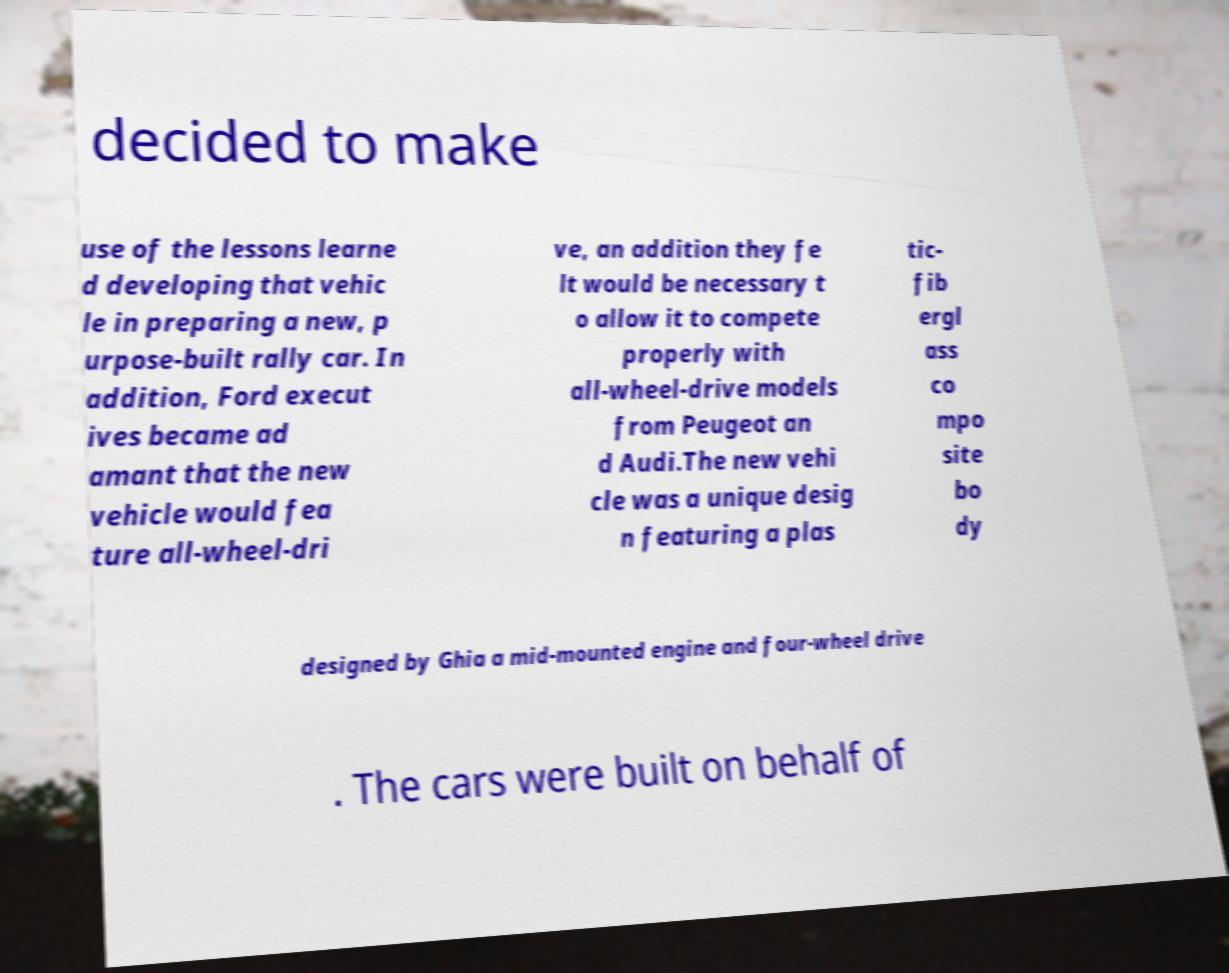Can you read and provide the text displayed in the image?This photo seems to have some interesting text. Can you extract and type it out for me? decided to make use of the lessons learne d developing that vehic le in preparing a new, p urpose-built rally car. In addition, Ford execut ives became ad amant that the new vehicle would fea ture all-wheel-dri ve, an addition they fe lt would be necessary t o allow it to compete properly with all-wheel-drive models from Peugeot an d Audi.The new vehi cle was a unique desig n featuring a plas tic- fib ergl ass co mpo site bo dy designed by Ghia a mid-mounted engine and four-wheel drive . The cars were built on behalf of 